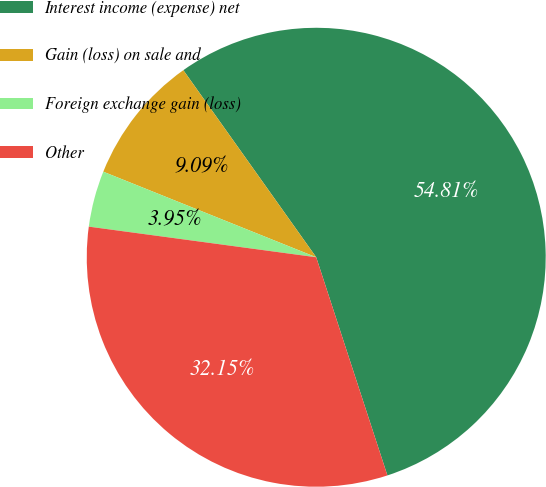Convert chart to OTSL. <chart><loc_0><loc_0><loc_500><loc_500><pie_chart><fcel>Interest income (expense) net<fcel>Gain (loss) on sale and<fcel>Foreign exchange gain (loss)<fcel>Other<nl><fcel>54.81%<fcel>9.09%<fcel>3.95%<fcel>32.15%<nl></chart> 